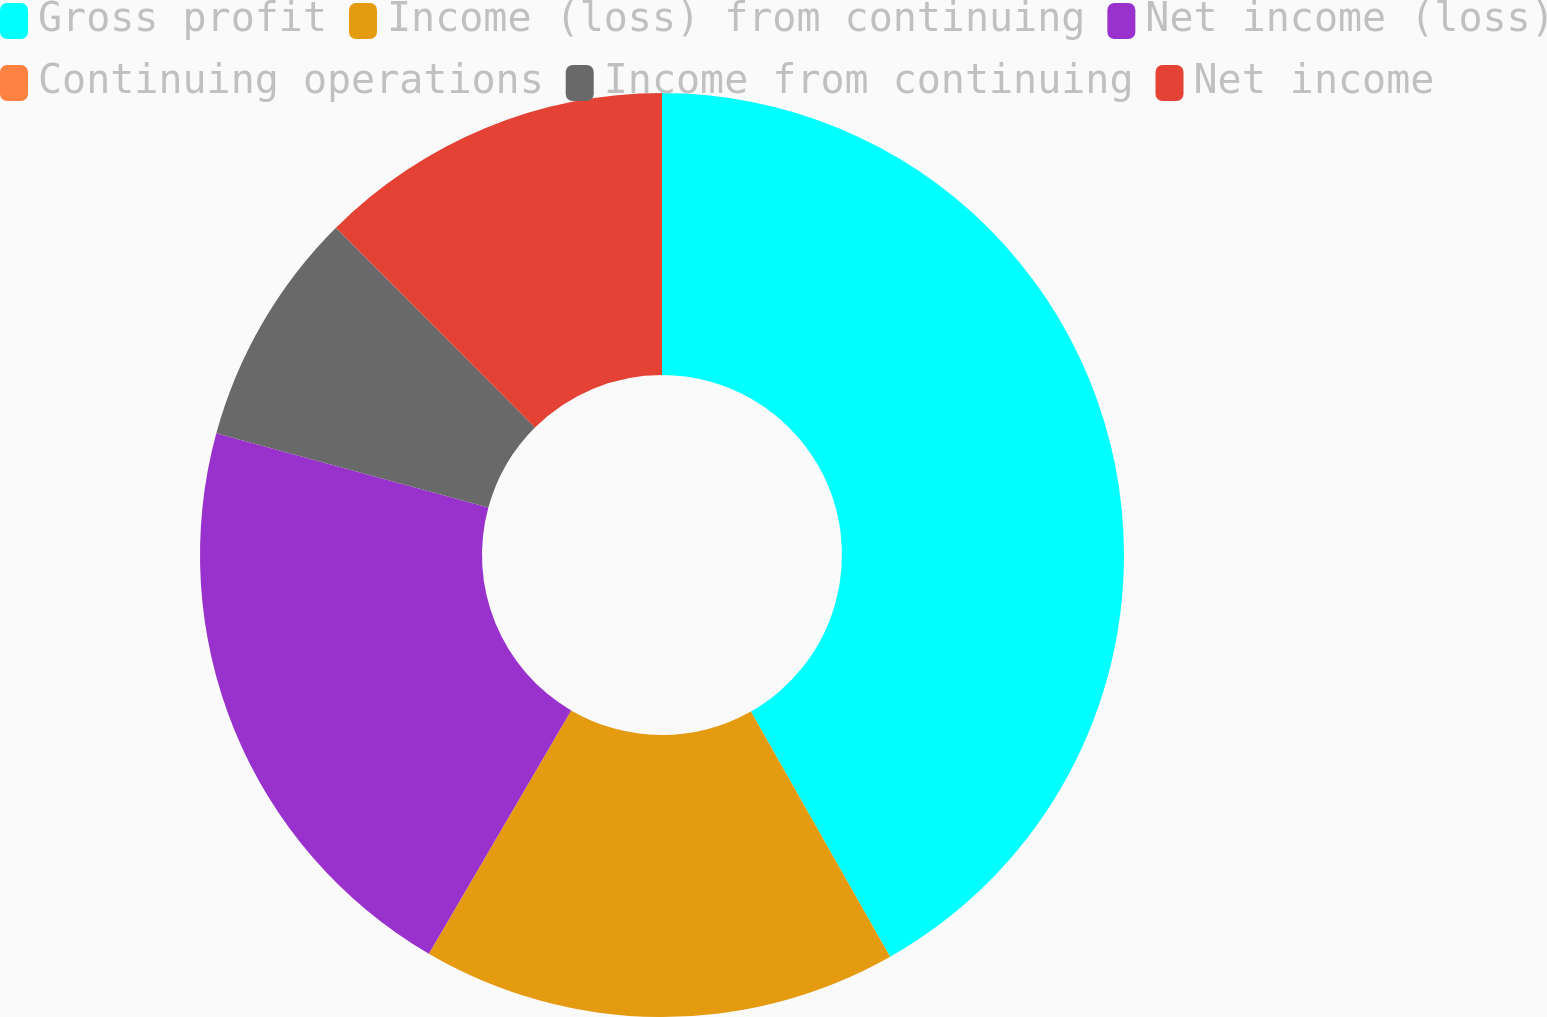Convert chart to OTSL. <chart><loc_0><loc_0><loc_500><loc_500><pie_chart><fcel>Gross profit<fcel>Income (loss) from continuing<fcel>Net income (loss)<fcel>Continuing operations<fcel>Income from continuing<fcel>Net income<nl><fcel>41.78%<fcel>16.64%<fcel>20.82%<fcel>0.0%<fcel>8.29%<fcel>12.47%<nl></chart> 